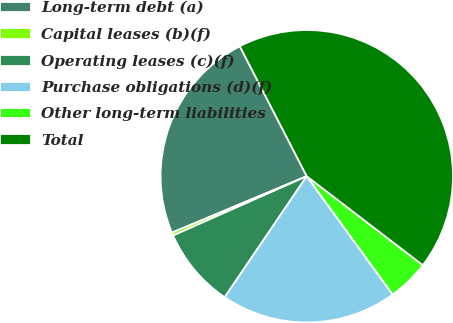Convert chart to OTSL. <chart><loc_0><loc_0><loc_500><loc_500><pie_chart><fcel>Long-term debt (a)<fcel>Capital leases (b)(f)<fcel>Operating leases (c)(f)<fcel>Purchase obligations (d)(f)<fcel>Other long-term liabilities<fcel>Total<nl><fcel>23.74%<fcel>0.34%<fcel>8.87%<fcel>19.48%<fcel>4.6%<fcel>42.98%<nl></chart> 